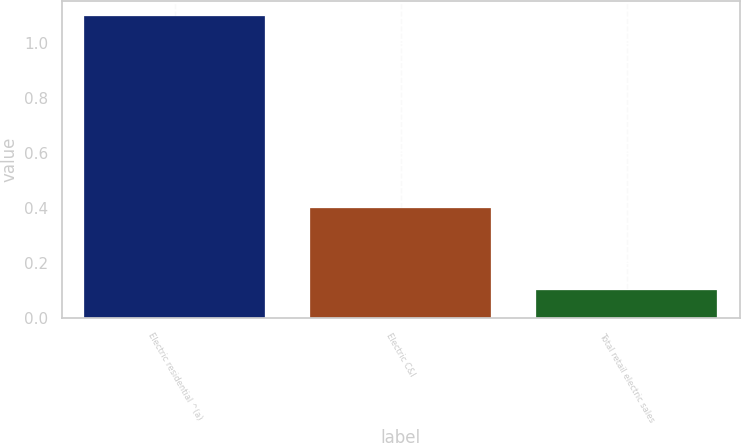Convert chart to OTSL. <chart><loc_0><loc_0><loc_500><loc_500><bar_chart><fcel>Electric residential ^(a)<fcel>Electric C&I<fcel>Total retail electric sales<nl><fcel>1.1<fcel>0.4<fcel>0.1<nl></chart> 